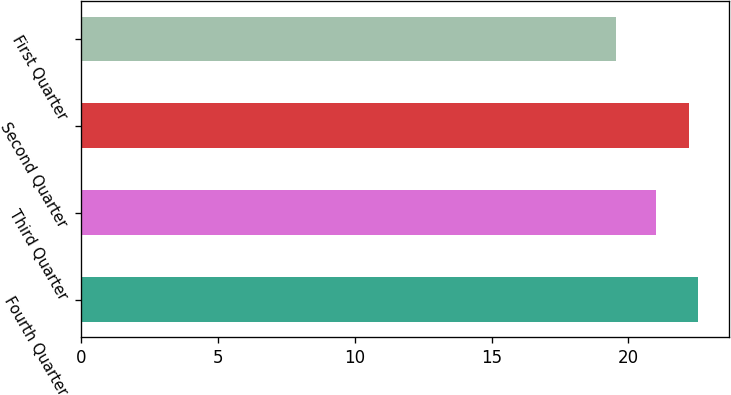Convert chart. <chart><loc_0><loc_0><loc_500><loc_500><bar_chart><fcel>Fourth Quarter<fcel>Third Quarter<fcel>Second Quarter<fcel>First Quarter<nl><fcel>22.55<fcel>21.01<fcel>22.22<fcel>19.56<nl></chart> 